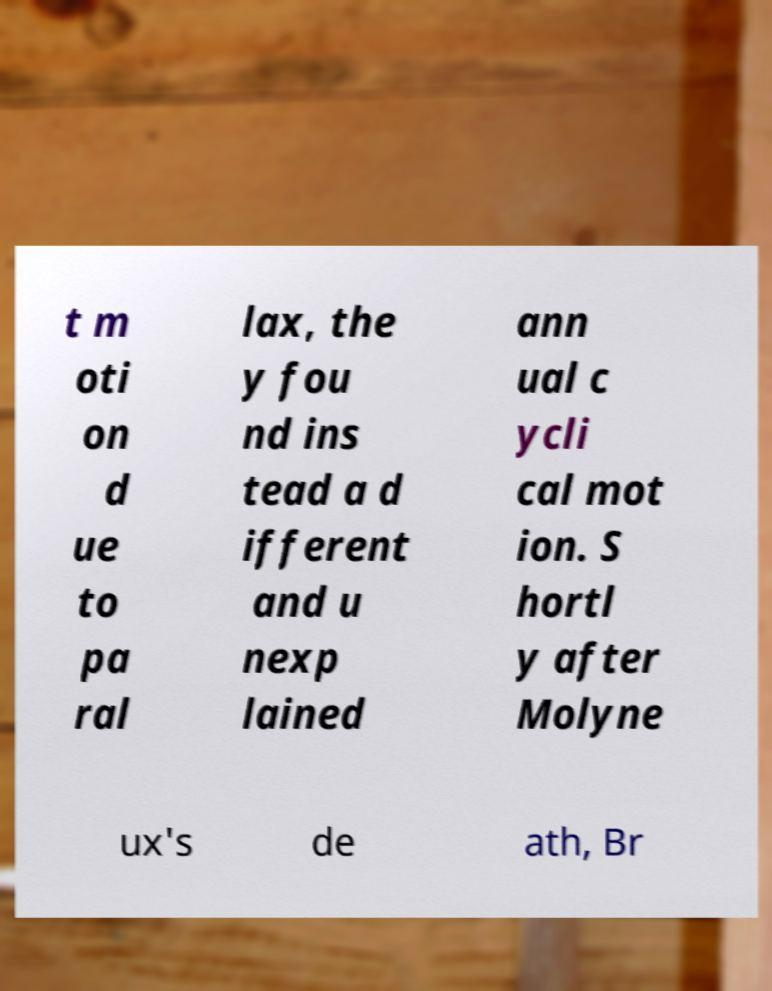Can you read and provide the text displayed in the image?This photo seems to have some interesting text. Can you extract and type it out for me? t m oti on d ue to pa ral lax, the y fou nd ins tead a d ifferent and u nexp lained ann ual c ycli cal mot ion. S hortl y after Molyne ux's de ath, Br 